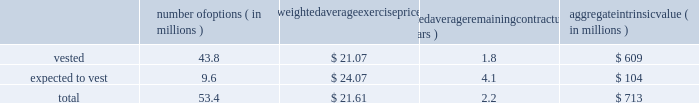Intel corporation notes to consolidated financial statements ( continued ) the aggregate fair value of awards that vested in 2015 was $ 1.5 billion ( $ 1.1 billion in 2014 and $ 1.0 billion in 2013 ) , which represents the market value of our common stock on the date that the rsus vested .
The grant-date fair value of awards that vested in 2015 was $ 1.1 billion ( $ 949 million in 2014 and $ 899 million in 2013 ) .
The number of rsus vested includes shares of common stock that we withheld on behalf of employees to satisfy the minimum statutory tax withholding requirements .
Rsus that are expected to vest are net of estimated future forfeitures .
As of december 26 , 2015 , there was $ 1.8 billion in unrecognized compensation costs related to rsus granted under our equity incentive plans .
We expect to recognize those costs over a weighted average period of 1.2 years .
Stock option awards as of december 26 , 2015 , options outstanding that have vested and are expected to vest were as follows : number of options ( in millions ) weighted average exercise weighted average remaining contractual ( in years ) aggregate intrinsic ( in millions ) .
Aggregate intrinsic value represents the difference between the exercise price and $ 34.98 , the closing price of our common stock on december 24 , 2015 , as reported on the nasdaq global select market , for all in-the-money options outstanding .
Options outstanding that are expected to vest are net of estimated future option forfeitures .
Options with a fair value of $ 42 million completed vesting in 2015 ( $ 68 million in 2014 and $ 186 million in 2013 ) .
As of december 26 , 2015 , there was $ 13 million in unrecognized compensation costs related to stock options granted under our equity incentive plans .
We expect to recognize those costs over a weighted average period of approximately eight months. .
As of december 26 , 2015 , what was the percent of the number of options vested to the total? 
Rationale: as of december 26 , 2015 , 82% of the total was made of the number of options vested
Computations: (43.8 / 53.4)
Answer: 0.82022. Intel corporation notes to consolidated financial statements ( continued ) the aggregate fair value of awards that vested in 2015 was $ 1.5 billion ( $ 1.1 billion in 2014 and $ 1.0 billion in 2013 ) , which represents the market value of our common stock on the date that the rsus vested .
The grant-date fair value of awards that vested in 2015 was $ 1.1 billion ( $ 949 million in 2014 and $ 899 million in 2013 ) .
The number of rsus vested includes shares of common stock that we withheld on behalf of employees to satisfy the minimum statutory tax withholding requirements .
Rsus that are expected to vest are net of estimated future forfeitures .
As of december 26 , 2015 , there was $ 1.8 billion in unrecognized compensation costs related to rsus granted under our equity incentive plans .
We expect to recognize those costs over a weighted average period of 1.2 years .
Stock option awards as of december 26 , 2015 , options outstanding that have vested and are expected to vest were as follows : number of options ( in millions ) weighted average exercise weighted average remaining contractual ( in years ) aggregate intrinsic ( in millions ) .
Aggregate intrinsic value represents the difference between the exercise price and $ 34.98 , the closing price of our common stock on december 24 , 2015 , as reported on the nasdaq global select market , for all in-the-money options outstanding .
Options outstanding that are expected to vest are net of estimated future option forfeitures .
Options with a fair value of $ 42 million completed vesting in 2015 ( $ 68 million in 2014 and $ 186 million in 2013 ) .
As of december 26 , 2015 , there was $ 13 million in unrecognized compensation costs related to stock options granted under our equity incentive plans .
We expect to recognize those costs over a weighted average period of approximately eight months. .
What percentage of stock option awards are vested as of december 26 , 2015? 
Computations: (43.8 / 53.4)
Answer: 0.82022. 